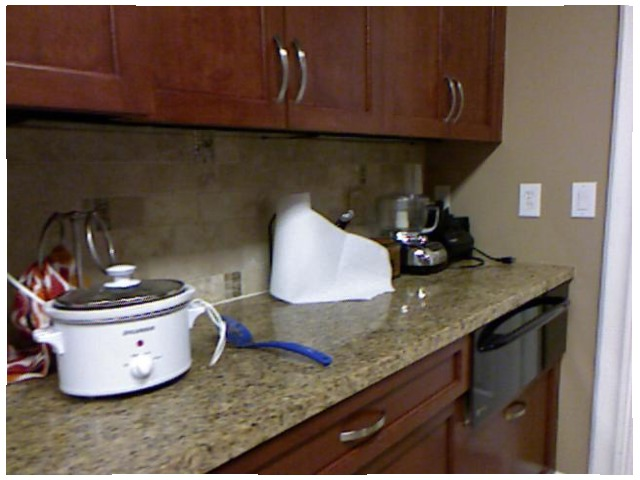<image>
Is there a cabinet under the counter? No. The cabinet is not positioned under the counter. The vertical relationship between these objects is different. Is there a handle on the drawer? Yes. Looking at the image, I can see the handle is positioned on top of the drawer, with the drawer providing support. Is there a pot behind the counter? No. The pot is not behind the counter. From this viewpoint, the pot appears to be positioned elsewhere in the scene. Where is the switch in relation to the wall? Is it in the wall? Yes. The switch is contained within or inside the wall, showing a containment relationship. Where is the spoon in relation to the crock pot? Is it in the crock pot? No. The spoon is not contained within the crock pot. These objects have a different spatial relationship. 